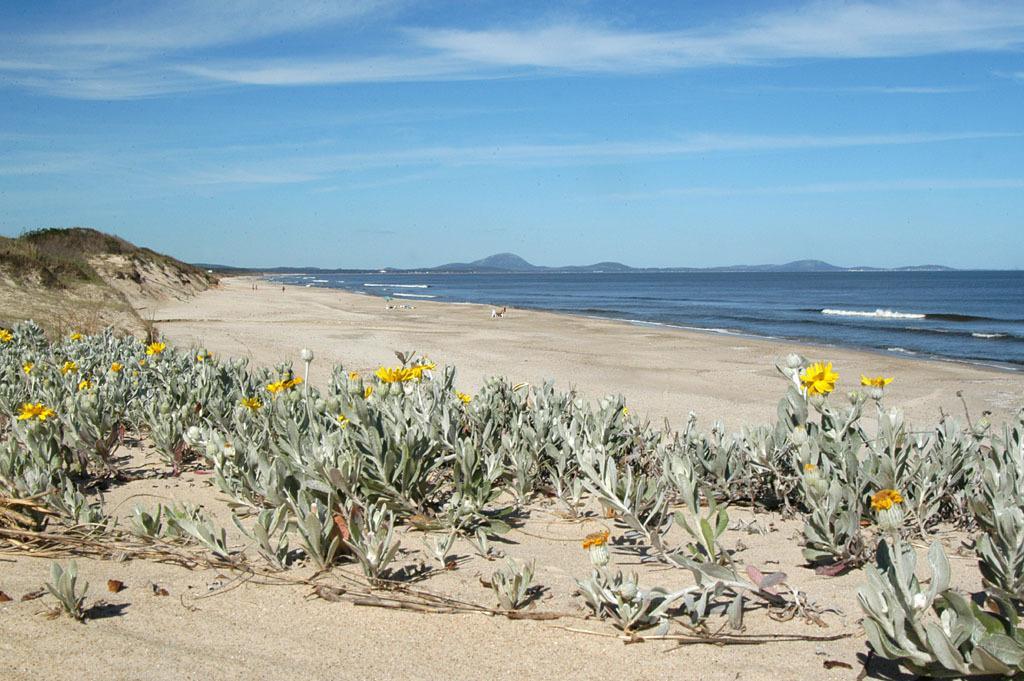Please provide a concise description of this image. In this image we can see plants with flowers, grass on the ground, objects, water, mountains and clouds in the sky. 